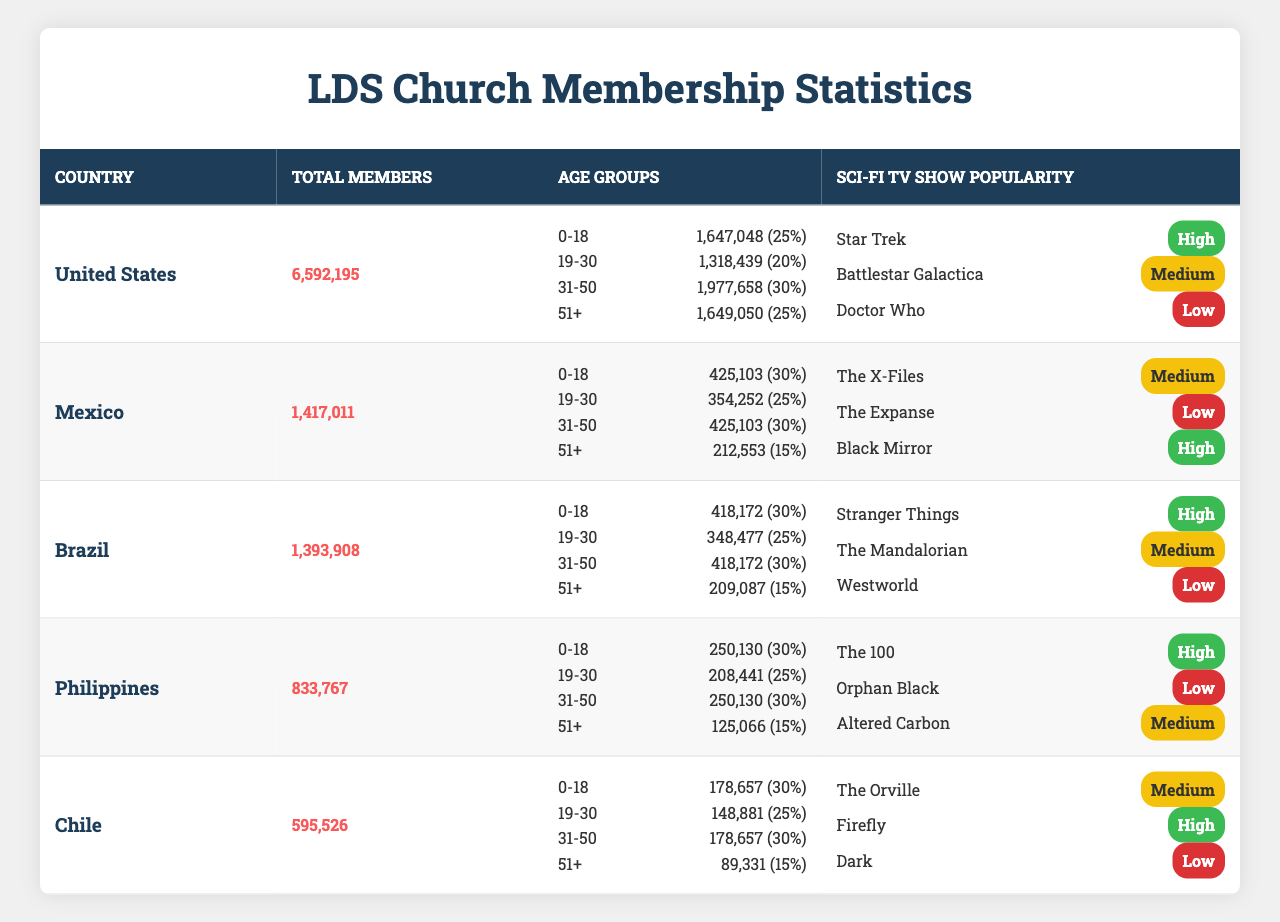What is the total number of LDS Church members in Brazil? The table shows that Brazil has a total of 1,393,908 members listed under the "Total Members" column.
Answer: 1,393,908 Which country has the highest percentage of members in the 0-18 age group? By looking at the percentages in the table, both Mexico and Brazil have 30% in the 0-18 age group, but Mexico has a higher total number of members in this age group (425,103 vs. 418,172).
Answer: Mexico and Brazil (30% each) What is the difference in the number of members in the 51+ age group between the United States and the Philippines? The number of members in the 51+ age group for the United States is 1,649,050, while for the Philippines it is 125,066. The difference is calculated as 1,649,050 - 125,066 = 1,523,984.
Answer: 1,523,984 What is the average number of LDS Church members across all age groups in Chile? In Chile, the total membership is 595,526. The number of members across all age groups is 178,657 (0-18) + 148,881 (19-30) + 178,657 (31-50) + 89,331 (51+) = 595,526, so the average is 595,526 / 4 = 148,881.5.
Answer: 148,881.5 Does any country have a higher number of members in the 31-50 age group than in the 0-18 age group? By examining the age group data, the United States, Mexico, and Brazil have higher numbers of members in the 31-50 age group compared to the 0-18 age group. For example, the United States has 1,977,658 (31-50) vs 1,647,048 (0-18).
Answer: Yes What is the total number of LDS Church members combined for the age group 19-30 across all countries? Adding the members in the 19-30 age group from each country gives: 1,318,439 (USA) + 354,252 (Mexico) + 348,477 (Brazil) + 208,441 (Philippines) + 148,881 (Chile) = 2,378,490.
Answer: 2,378,490 Which sci-fi TV show has the lowest popularity rating in the United States? Review of the "Sci-Fi TV Show Popularity" section for the United States shows "Doctor Who" with a popularity rating of "Low".
Answer: Doctor Who Is the total number of LDS Church members in Mexico higher or lower than that in the Philippines? The total number of members in Mexico is 1,417,011, while in the Philippines it is 833,767. Therefore, Mexico has a higher total membership.
Answer: Higher What percentage of the total membership does the 51+ age group represent in the United States? The 51+ age group has 1,649,050 members out of 6,592,195 total members in the United States. To find the percentage, calculate (1,649,050 / 6,592,195) * 100 ≈ 25%.
Answer: 25% Which country has the lowest total number of LDS Church members? The table shows that Chile has the lowest total number of members at 595,526, compared to the other countries listed.
Answer: Chile 